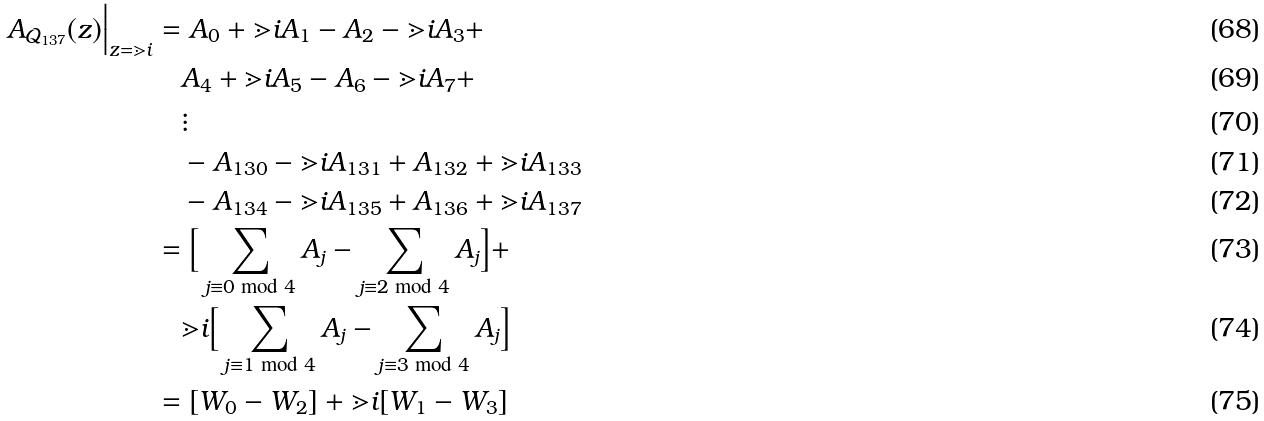<formula> <loc_0><loc_0><loc_500><loc_500>A _ { \mathcal { Q } _ { 1 3 7 } } ( z ) \Big | _ { z = \mathbb { m } { i } } & = A _ { 0 } + \mathbb { m } { i } A _ { 1 } - A _ { 2 } - \mathbb { m } { i } A _ { 3 } + \\ & \quad A _ { 4 } + \mathbb { m } { i } A _ { 5 } - A _ { 6 } - \mathbb { m } { i } A _ { 7 } + \\ & \quad \vdots \\ & \quad - A _ { 1 3 0 } - \mathbb { m } { i } A _ { 1 3 1 } + A _ { 1 3 2 } + \mathbb { m } { i } A _ { 1 3 3 } \\ & \quad - A _ { 1 3 4 } - \mathbb { m } { i } A _ { 1 3 5 } + A _ { 1 3 6 } + \mathbb { m } { i } A _ { 1 3 7 } \\ & = \Big [ \sum _ { j \equiv 0 \bmod { 4 } } A _ { j } - \sum _ { j \equiv 2 \bmod { 4 } } A _ { j } \Big ] + \\ & \quad \mathbb { m } { i } \Big [ \sum _ { j \equiv 1 \bmod { 4 } } A _ { j } - \sum _ { j \equiv 3 \bmod { 4 } } A _ { j } \Big ] \\ & = [ W _ { 0 } - W _ { 2 } ] + \mathbb { m } { i } [ W _ { 1 } - W _ { 3 } ]</formula> 